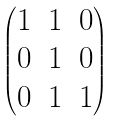Convert formula to latex. <formula><loc_0><loc_0><loc_500><loc_500>\begin{pmatrix} 1 & 1 & 0 \\ 0 & 1 & 0 \\ 0 & 1 & 1 \end{pmatrix}</formula> 